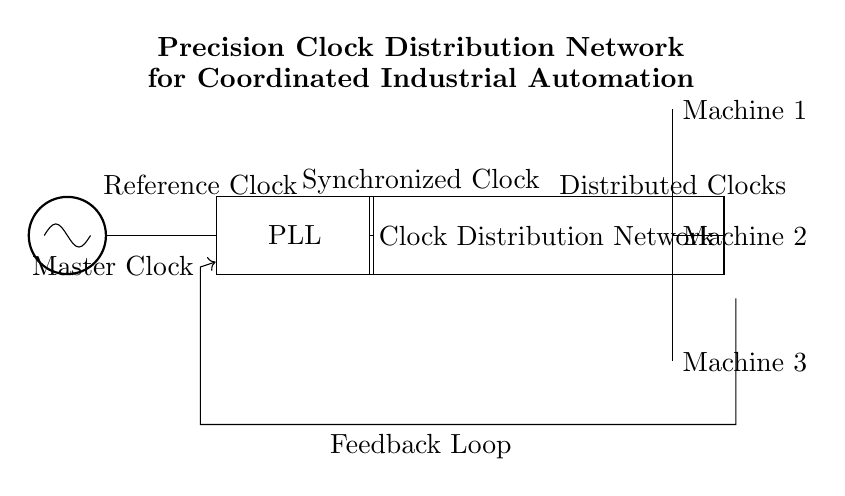What is the primary function of the Master Clock? The Master Clock is the primary oscillator that generates the reference clock signal required for the entire synchronizing process in the circuit.
Answer: Clock generation What component uses feedback to maintain synchronization? The phase-locked loop (PLL) uses feedback from the output to adjust its operation and synchronize the clock signals effectively.
Answer: PLL How many machines receive the distributed clocks? There are three machines indicated in the circuit, each receiving a pulse from the Clock Distribution Network.
Answer: Three What is the function of the Clock Distribution Network? The Clock Distribution Network distributes the synchronized clock signals coming from the PLL to multiple machines, ensuring that all machines operate in coordination.
Answer: Clock distribution What type of clock is used as a reference in this circuit? The circuit uses an oscillator-generated reference clock, which serves as a basis for synchronizing all other clock signals through the PLL and Clock Distribution Network.
Answer: Reference clock 